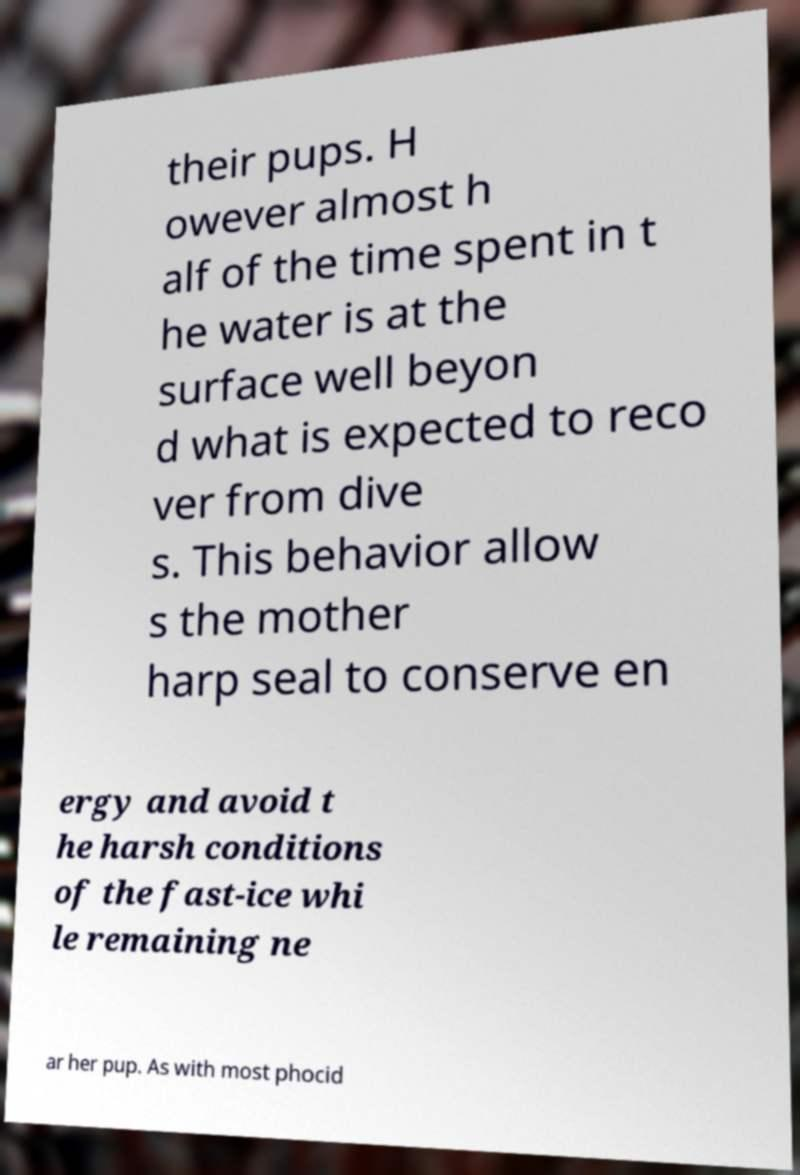For documentation purposes, I need the text within this image transcribed. Could you provide that? their pups. H owever almost h alf of the time spent in t he water is at the surface well beyon d what is expected to reco ver from dive s. This behavior allow s the mother harp seal to conserve en ergy and avoid t he harsh conditions of the fast-ice whi le remaining ne ar her pup. As with most phocid 